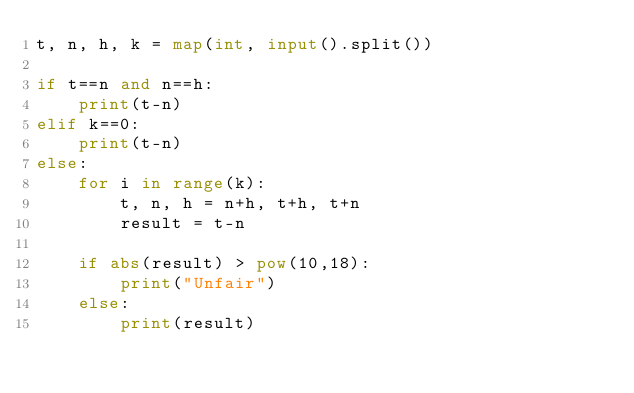Convert code to text. <code><loc_0><loc_0><loc_500><loc_500><_Python_>t, n, h, k = map(int, input().split())

if t==n and n==h:
    print(t-n)
elif k==0:
    print(t-n)
else:
    for i in range(k):
        t, n, h = n+h, t+h, t+n
        result = t-n

    if abs(result) > pow(10,18):
        print("Unfair")
    else:
        print(result)</code> 